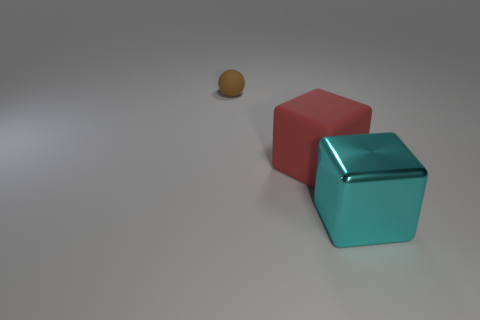Subtract all brown blocks. Subtract all red balls. How many blocks are left? 2 Add 3 tiny brown objects. How many objects exist? 6 Subtract all spheres. How many objects are left? 2 Add 1 balls. How many balls are left? 2 Add 3 big metal things. How many big metal things exist? 4 Subtract 0 green cubes. How many objects are left? 3 Subtract all large cyan blocks. Subtract all small matte objects. How many objects are left? 1 